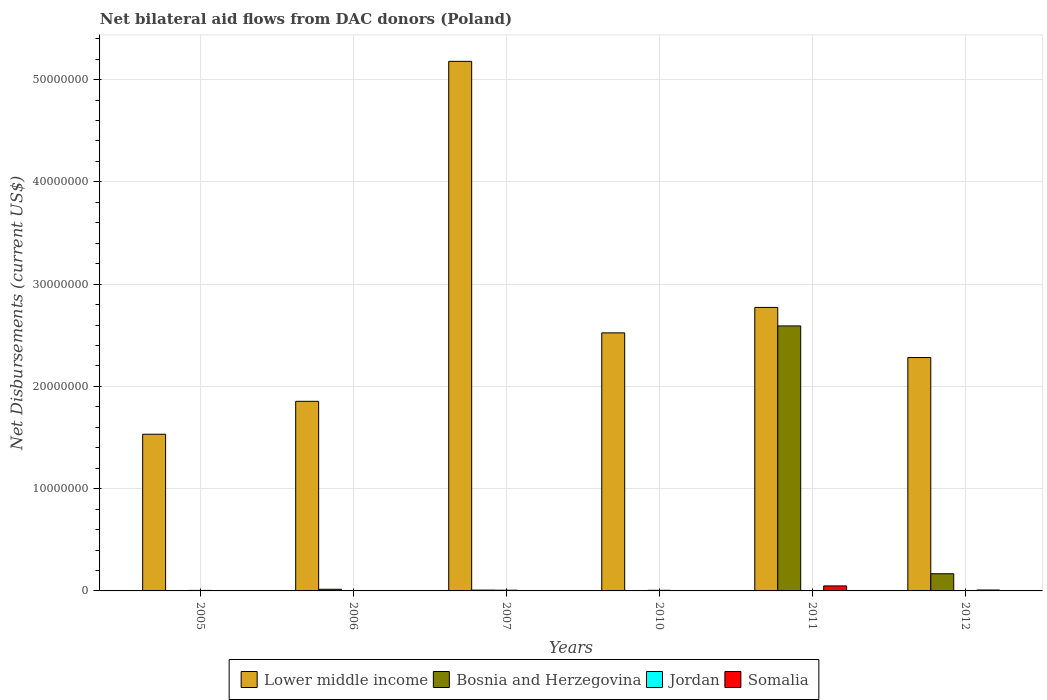How many groups of bars are there?
Give a very brief answer. 6. Are the number of bars per tick equal to the number of legend labels?
Your response must be concise. Yes. In how many cases, is the number of bars for a given year not equal to the number of legend labels?
Make the answer very short. 0. What is the net bilateral aid flows in Lower middle income in 2005?
Make the answer very short. 1.53e+07. Across all years, what is the maximum net bilateral aid flows in Bosnia and Herzegovina?
Offer a very short reply. 2.59e+07. Across all years, what is the minimum net bilateral aid flows in Jordan?
Keep it short and to the point. 10000. What is the total net bilateral aid flows in Bosnia and Herzegovina in the graph?
Provide a short and direct response. 2.78e+07. What is the difference between the net bilateral aid flows in Jordan in 2007 and that in 2010?
Offer a very short reply. 10000. What is the difference between the net bilateral aid flows in Somalia in 2007 and the net bilateral aid flows in Jordan in 2011?
Your answer should be compact. -2.00e+04. What is the average net bilateral aid flows in Somalia per year?
Your answer should be very brief. 1.07e+05. In the year 2007, what is the difference between the net bilateral aid flows in Jordan and net bilateral aid flows in Somalia?
Your answer should be very brief. 5.00e+04. What is the ratio of the net bilateral aid flows in Lower middle income in 2006 to that in 2010?
Give a very brief answer. 0.73. What is the difference between the highest and the second highest net bilateral aid flows in Somalia?
Your response must be concise. 4.00e+05. What is the difference between the highest and the lowest net bilateral aid flows in Bosnia and Herzegovina?
Make the answer very short. 2.59e+07. In how many years, is the net bilateral aid flows in Somalia greater than the average net bilateral aid flows in Somalia taken over all years?
Make the answer very short. 1. What does the 4th bar from the left in 2005 represents?
Keep it short and to the point. Somalia. What does the 4th bar from the right in 2006 represents?
Give a very brief answer. Lower middle income. Is it the case that in every year, the sum of the net bilateral aid flows in Somalia and net bilateral aid flows in Lower middle income is greater than the net bilateral aid flows in Bosnia and Herzegovina?
Your response must be concise. Yes. How many bars are there?
Your response must be concise. 24. Are all the bars in the graph horizontal?
Your answer should be very brief. No. How many years are there in the graph?
Make the answer very short. 6. Where does the legend appear in the graph?
Your answer should be very brief. Bottom center. How many legend labels are there?
Keep it short and to the point. 4. What is the title of the graph?
Ensure brevity in your answer.  Net bilateral aid flows from DAC donors (Poland). What is the label or title of the Y-axis?
Your answer should be compact. Net Disbursements (current US$). What is the Net Disbursements (current US$) of Lower middle income in 2005?
Keep it short and to the point. 1.53e+07. What is the Net Disbursements (current US$) in Bosnia and Herzegovina in 2005?
Keep it short and to the point. 10000. What is the Net Disbursements (current US$) of Jordan in 2005?
Your answer should be compact. 5.00e+04. What is the Net Disbursements (current US$) in Lower middle income in 2006?
Ensure brevity in your answer.  1.85e+07. What is the Net Disbursements (current US$) in Bosnia and Herzegovina in 2006?
Give a very brief answer. 1.60e+05. What is the Net Disbursements (current US$) of Jordan in 2006?
Provide a succinct answer. 10000. What is the Net Disbursements (current US$) in Lower middle income in 2007?
Give a very brief answer. 5.18e+07. What is the Net Disbursements (current US$) in Bosnia and Herzegovina in 2007?
Offer a terse response. 8.00e+04. What is the Net Disbursements (current US$) in Jordan in 2007?
Ensure brevity in your answer.  7.00e+04. What is the Net Disbursements (current US$) in Somalia in 2007?
Provide a short and direct response. 2.00e+04. What is the Net Disbursements (current US$) in Lower middle income in 2010?
Your answer should be compact. 2.52e+07. What is the Net Disbursements (current US$) of Bosnia and Herzegovina in 2010?
Keep it short and to the point. 10000. What is the Net Disbursements (current US$) of Somalia in 2010?
Provide a short and direct response. 10000. What is the Net Disbursements (current US$) in Lower middle income in 2011?
Ensure brevity in your answer.  2.77e+07. What is the Net Disbursements (current US$) in Bosnia and Herzegovina in 2011?
Your response must be concise. 2.59e+07. What is the Net Disbursements (current US$) of Jordan in 2011?
Provide a short and direct response. 4.00e+04. What is the Net Disbursements (current US$) of Lower middle income in 2012?
Your answer should be very brief. 2.28e+07. What is the Net Disbursements (current US$) of Bosnia and Herzegovina in 2012?
Your answer should be compact. 1.68e+06. What is the Net Disbursements (current US$) of Jordan in 2012?
Your answer should be compact. 2.00e+04. Across all years, what is the maximum Net Disbursements (current US$) in Lower middle income?
Your answer should be compact. 5.18e+07. Across all years, what is the maximum Net Disbursements (current US$) of Bosnia and Herzegovina?
Ensure brevity in your answer.  2.59e+07. Across all years, what is the maximum Net Disbursements (current US$) in Jordan?
Your answer should be very brief. 7.00e+04. Across all years, what is the maximum Net Disbursements (current US$) of Somalia?
Your answer should be very brief. 4.90e+05. Across all years, what is the minimum Net Disbursements (current US$) in Lower middle income?
Provide a short and direct response. 1.53e+07. Across all years, what is the minimum Net Disbursements (current US$) in Bosnia and Herzegovina?
Your answer should be compact. 10000. Across all years, what is the minimum Net Disbursements (current US$) in Jordan?
Ensure brevity in your answer.  10000. What is the total Net Disbursements (current US$) in Lower middle income in the graph?
Provide a succinct answer. 1.61e+08. What is the total Net Disbursements (current US$) of Bosnia and Herzegovina in the graph?
Offer a terse response. 2.78e+07. What is the total Net Disbursements (current US$) in Somalia in the graph?
Make the answer very short. 6.40e+05. What is the difference between the Net Disbursements (current US$) in Lower middle income in 2005 and that in 2006?
Give a very brief answer. -3.22e+06. What is the difference between the Net Disbursements (current US$) of Jordan in 2005 and that in 2006?
Your answer should be very brief. 4.00e+04. What is the difference between the Net Disbursements (current US$) in Somalia in 2005 and that in 2006?
Ensure brevity in your answer.  -10000. What is the difference between the Net Disbursements (current US$) in Lower middle income in 2005 and that in 2007?
Provide a short and direct response. -3.65e+07. What is the difference between the Net Disbursements (current US$) in Somalia in 2005 and that in 2007?
Provide a succinct answer. -10000. What is the difference between the Net Disbursements (current US$) of Lower middle income in 2005 and that in 2010?
Your response must be concise. -9.91e+06. What is the difference between the Net Disbursements (current US$) of Bosnia and Herzegovina in 2005 and that in 2010?
Provide a succinct answer. 0. What is the difference between the Net Disbursements (current US$) in Lower middle income in 2005 and that in 2011?
Your answer should be compact. -1.24e+07. What is the difference between the Net Disbursements (current US$) of Bosnia and Herzegovina in 2005 and that in 2011?
Ensure brevity in your answer.  -2.59e+07. What is the difference between the Net Disbursements (current US$) of Somalia in 2005 and that in 2011?
Your answer should be very brief. -4.80e+05. What is the difference between the Net Disbursements (current US$) of Lower middle income in 2005 and that in 2012?
Give a very brief answer. -7.50e+06. What is the difference between the Net Disbursements (current US$) of Bosnia and Herzegovina in 2005 and that in 2012?
Provide a succinct answer. -1.67e+06. What is the difference between the Net Disbursements (current US$) of Jordan in 2005 and that in 2012?
Make the answer very short. 3.00e+04. What is the difference between the Net Disbursements (current US$) in Somalia in 2005 and that in 2012?
Provide a short and direct response. -8.00e+04. What is the difference between the Net Disbursements (current US$) in Lower middle income in 2006 and that in 2007?
Your answer should be very brief. -3.32e+07. What is the difference between the Net Disbursements (current US$) in Lower middle income in 2006 and that in 2010?
Give a very brief answer. -6.69e+06. What is the difference between the Net Disbursements (current US$) of Bosnia and Herzegovina in 2006 and that in 2010?
Give a very brief answer. 1.50e+05. What is the difference between the Net Disbursements (current US$) in Somalia in 2006 and that in 2010?
Your answer should be compact. 10000. What is the difference between the Net Disbursements (current US$) in Lower middle income in 2006 and that in 2011?
Provide a succinct answer. -9.18e+06. What is the difference between the Net Disbursements (current US$) in Bosnia and Herzegovina in 2006 and that in 2011?
Make the answer very short. -2.58e+07. What is the difference between the Net Disbursements (current US$) in Jordan in 2006 and that in 2011?
Your answer should be compact. -3.00e+04. What is the difference between the Net Disbursements (current US$) in Somalia in 2006 and that in 2011?
Make the answer very short. -4.70e+05. What is the difference between the Net Disbursements (current US$) in Lower middle income in 2006 and that in 2012?
Your response must be concise. -4.28e+06. What is the difference between the Net Disbursements (current US$) in Bosnia and Herzegovina in 2006 and that in 2012?
Offer a terse response. -1.52e+06. What is the difference between the Net Disbursements (current US$) in Somalia in 2006 and that in 2012?
Offer a very short reply. -7.00e+04. What is the difference between the Net Disbursements (current US$) of Lower middle income in 2007 and that in 2010?
Offer a terse response. 2.66e+07. What is the difference between the Net Disbursements (current US$) in Jordan in 2007 and that in 2010?
Provide a short and direct response. 10000. What is the difference between the Net Disbursements (current US$) of Somalia in 2007 and that in 2010?
Ensure brevity in your answer.  10000. What is the difference between the Net Disbursements (current US$) in Lower middle income in 2007 and that in 2011?
Your response must be concise. 2.41e+07. What is the difference between the Net Disbursements (current US$) in Bosnia and Herzegovina in 2007 and that in 2011?
Provide a succinct answer. -2.58e+07. What is the difference between the Net Disbursements (current US$) of Somalia in 2007 and that in 2011?
Offer a very short reply. -4.70e+05. What is the difference between the Net Disbursements (current US$) in Lower middle income in 2007 and that in 2012?
Provide a succinct answer. 2.90e+07. What is the difference between the Net Disbursements (current US$) in Bosnia and Herzegovina in 2007 and that in 2012?
Provide a succinct answer. -1.60e+06. What is the difference between the Net Disbursements (current US$) in Lower middle income in 2010 and that in 2011?
Your response must be concise. -2.49e+06. What is the difference between the Net Disbursements (current US$) in Bosnia and Herzegovina in 2010 and that in 2011?
Provide a succinct answer. -2.59e+07. What is the difference between the Net Disbursements (current US$) of Jordan in 2010 and that in 2011?
Offer a terse response. 2.00e+04. What is the difference between the Net Disbursements (current US$) in Somalia in 2010 and that in 2011?
Offer a very short reply. -4.80e+05. What is the difference between the Net Disbursements (current US$) in Lower middle income in 2010 and that in 2012?
Provide a succinct answer. 2.41e+06. What is the difference between the Net Disbursements (current US$) of Bosnia and Herzegovina in 2010 and that in 2012?
Give a very brief answer. -1.67e+06. What is the difference between the Net Disbursements (current US$) in Somalia in 2010 and that in 2012?
Give a very brief answer. -8.00e+04. What is the difference between the Net Disbursements (current US$) in Lower middle income in 2011 and that in 2012?
Make the answer very short. 4.90e+06. What is the difference between the Net Disbursements (current US$) in Bosnia and Herzegovina in 2011 and that in 2012?
Give a very brief answer. 2.42e+07. What is the difference between the Net Disbursements (current US$) of Jordan in 2011 and that in 2012?
Your response must be concise. 2.00e+04. What is the difference between the Net Disbursements (current US$) of Lower middle income in 2005 and the Net Disbursements (current US$) of Bosnia and Herzegovina in 2006?
Give a very brief answer. 1.52e+07. What is the difference between the Net Disbursements (current US$) in Lower middle income in 2005 and the Net Disbursements (current US$) in Jordan in 2006?
Offer a very short reply. 1.53e+07. What is the difference between the Net Disbursements (current US$) in Lower middle income in 2005 and the Net Disbursements (current US$) in Somalia in 2006?
Offer a very short reply. 1.53e+07. What is the difference between the Net Disbursements (current US$) of Bosnia and Herzegovina in 2005 and the Net Disbursements (current US$) of Jordan in 2006?
Your answer should be compact. 0. What is the difference between the Net Disbursements (current US$) of Bosnia and Herzegovina in 2005 and the Net Disbursements (current US$) of Somalia in 2006?
Keep it short and to the point. -10000. What is the difference between the Net Disbursements (current US$) of Lower middle income in 2005 and the Net Disbursements (current US$) of Bosnia and Herzegovina in 2007?
Make the answer very short. 1.52e+07. What is the difference between the Net Disbursements (current US$) of Lower middle income in 2005 and the Net Disbursements (current US$) of Jordan in 2007?
Make the answer very short. 1.52e+07. What is the difference between the Net Disbursements (current US$) in Lower middle income in 2005 and the Net Disbursements (current US$) in Somalia in 2007?
Your answer should be compact. 1.53e+07. What is the difference between the Net Disbursements (current US$) in Jordan in 2005 and the Net Disbursements (current US$) in Somalia in 2007?
Provide a short and direct response. 3.00e+04. What is the difference between the Net Disbursements (current US$) of Lower middle income in 2005 and the Net Disbursements (current US$) of Bosnia and Herzegovina in 2010?
Offer a terse response. 1.53e+07. What is the difference between the Net Disbursements (current US$) of Lower middle income in 2005 and the Net Disbursements (current US$) of Jordan in 2010?
Your response must be concise. 1.53e+07. What is the difference between the Net Disbursements (current US$) in Lower middle income in 2005 and the Net Disbursements (current US$) in Somalia in 2010?
Your response must be concise. 1.53e+07. What is the difference between the Net Disbursements (current US$) of Bosnia and Herzegovina in 2005 and the Net Disbursements (current US$) of Somalia in 2010?
Your answer should be very brief. 0. What is the difference between the Net Disbursements (current US$) of Lower middle income in 2005 and the Net Disbursements (current US$) of Bosnia and Herzegovina in 2011?
Your answer should be very brief. -1.06e+07. What is the difference between the Net Disbursements (current US$) of Lower middle income in 2005 and the Net Disbursements (current US$) of Jordan in 2011?
Offer a terse response. 1.53e+07. What is the difference between the Net Disbursements (current US$) in Lower middle income in 2005 and the Net Disbursements (current US$) in Somalia in 2011?
Ensure brevity in your answer.  1.48e+07. What is the difference between the Net Disbursements (current US$) of Bosnia and Herzegovina in 2005 and the Net Disbursements (current US$) of Somalia in 2011?
Your answer should be very brief. -4.80e+05. What is the difference between the Net Disbursements (current US$) in Jordan in 2005 and the Net Disbursements (current US$) in Somalia in 2011?
Offer a very short reply. -4.40e+05. What is the difference between the Net Disbursements (current US$) in Lower middle income in 2005 and the Net Disbursements (current US$) in Bosnia and Herzegovina in 2012?
Provide a short and direct response. 1.36e+07. What is the difference between the Net Disbursements (current US$) of Lower middle income in 2005 and the Net Disbursements (current US$) of Jordan in 2012?
Provide a succinct answer. 1.53e+07. What is the difference between the Net Disbursements (current US$) of Lower middle income in 2005 and the Net Disbursements (current US$) of Somalia in 2012?
Your response must be concise. 1.52e+07. What is the difference between the Net Disbursements (current US$) of Bosnia and Herzegovina in 2005 and the Net Disbursements (current US$) of Jordan in 2012?
Your answer should be compact. -10000. What is the difference between the Net Disbursements (current US$) of Bosnia and Herzegovina in 2005 and the Net Disbursements (current US$) of Somalia in 2012?
Your answer should be very brief. -8.00e+04. What is the difference between the Net Disbursements (current US$) in Lower middle income in 2006 and the Net Disbursements (current US$) in Bosnia and Herzegovina in 2007?
Make the answer very short. 1.85e+07. What is the difference between the Net Disbursements (current US$) in Lower middle income in 2006 and the Net Disbursements (current US$) in Jordan in 2007?
Your response must be concise. 1.85e+07. What is the difference between the Net Disbursements (current US$) in Lower middle income in 2006 and the Net Disbursements (current US$) in Somalia in 2007?
Your response must be concise. 1.85e+07. What is the difference between the Net Disbursements (current US$) in Bosnia and Herzegovina in 2006 and the Net Disbursements (current US$) in Jordan in 2007?
Offer a terse response. 9.00e+04. What is the difference between the Net Disbursements (current US$) of Lower middle income in 2006 and the Net Disbursements (current US$) of Bosnia and Herzegovina in 2010?
Keep it short and to the point. 1.85e+07. What is the difference between the Net Disbursements (current US$) of Lower middle income in 2006 and the Net Disbursements (current US$) of Jordan in 2010?
Your response must be concise. 1.85e+07. What is the difference between the Net Disbursements (current US$) in Lower middle income in 2006 and the Net Disbursements (current US$) in Somalia in 2010?
Offer a terse response. 1.85e+07. What is the difference between the Net Disbursements (current US$) of Bosnia and Herzegovina in 2006 and the Net Disbursements (current US$) of Jordan in 2010?
Your answer should be very brief. 1.00e+05. What is the difference between the Net Disbursements (current US$) in Bosnia and Herzegovina in 2006 and the Net Disbursements (current US$) in Somalia in 2010?
Offer a very short reply. 1.50e+05. What is the difference between the Net Disbursements (current US$) of Jordan in 2006 and the Net Disbursements (current US$) of Somalia in 2010?
Keep it short and to the point. 0. What is the difference between the Net Disbursements (current US$) of Lower middle income in 2006 and the Net Disbursements (current US$) of Bosnia and Herzegovina in 2011?
Keep it short and to the point. -7.37e+06. What is the difference between the Net Disbursements (current US$) of Lower middle income in 2006 and the Net Disbursements (current US$) of Jordan in 2011?
Your answer should be compact. 1.85e+07. What is the difference between the Net Disbursements (current US$) of Lower middle income in 2006 and the Net Disbursements (current US$) of Somalia in 2011?
Your answer should be compact. 1.80e+07. What is the difference between the Net Disbursements (current US$) in Bosnia and Herzegovina in 2006 and the Net Disbursements (current US$) in Jordan in 2011?
Your answer should be compact. 1.20e+05. What is the difference between the Net Disbursements (current US$) of Bosnia and Herzegovina in 2006 and the Net Disbursements (current US$) of Somalia in 2011?
Offer a very short reply. -3.30e+05. What is the difference between the Net Disbursements (current US$) in Jordan in 2006 and the Net Disbursements (current US$) in Somalia in 2011?
Offer a terse response. -4.80e+05. What is the difference between the Net Disbursements (current US$) in Lower middle income in 2006 and the Net Disbursements (current US$) in Bosnia and Herzegovina in 2012?
Your answer should be compact. 1.69e+07. What is the difference between the Net Disbursements (current US$) in Lower middle income in 2006 and the Net Disbursements (current US$) in Jordan in 2012?
Give a very brief answer. 1.85e+07. What is the difference between the Net Disbursements (current US$) of Lower middle income in 2006 and the Net Disbursements (current US$) of Somalia in 2012?
Give a very brief answer. 1.84e+07. What is the difference between the Net Disbursements (current US$) of Bosnia and Herzegovina in 2006 and the Net Disbursements (current US$) of Jordan in 2012?
Offer a terse response. 1.40e+05. What is the difference between the Net Disbursements (current US$) in Bosnia and Herzegovina in 2006 and the Net Disbursements (current US$) in Somalia in 2012?
Ensure brevity in your answer.  7.00e+04. What is the difference between the Net Disbursements (current US$) in Lower middle income in 2007 and the Net Disbursements (current US$) in Bosnia and Herzegovina in 2010?
Your response must be concise. 5.18e+07. What is the difference between the Net Disbursements (current US$) of Lower middle income in 2007 and the Net Disbursements (current US$) of Jordan in 2010?
Offer a very short reply. 5.17e+07. What is the difference between the Net Disbursements (current US$) of Lower middle income in 2007 and the Net Disbursements (current US$) of Somalia in 2010?
Give a very brief answer. 5.18e+07. What is the difference between the Net Disbursements (current US$) of Bosnia and Herzegovina in 2007 and the Net Disbursements (current US$) of Somalia in 2010?
Your response must be concise. 7.00e+04. What is the difference between the Net Disbursements (current US$) of Lower middle income in 2007 and the Net Disbursements (current US$) of Bosnia and Herzegovina in 2011?
Make the answer very short. 2.59e+07. What is the difference between the Net Disbursements (current US$) in Lower middle income in 2007 and the Net Disbursements (current US$) in Jordan in 2011?
Your answer should be very brief. 5.17e+07. What is the difference between the Net Disbursements (current US$) of Lower middle income in 2007 and the Net Disbursements (current US$) of Somalia in 2011?
Your response must be concise. 5.13e+07. What is the difference between the Net Disbursements (current US$) of Bosnia and Herzegovina in 2007 and the Net Disbursements (current US$) of Somalia in 2011?
Ensure brevity in your answer.  -4.10e+05. What is the difference between the Net Disbursements (current US$) in Jordan in 2007 and the Net Disbursements (current US$) in Somalia in 2011?
Ensure brevity in your answer.  -4.20e+05. What is the difference between the Net Disbursements (current US$) in Lower middle income in 2007 and the Net Disbursements (current US$) in Bosnia and Herzegovina in 2012?
Offer a terse response. 5.01e+07. What is the difference between the Net Disbursements (current US$) in Lower middle income in 2007 and the Net Disbursements (current US$) in Jordan in 2012?
Make the answer very short. 5.18e+07. What is the difference between the Net Disbursements (current US$) of Lower middle income in 2007 and the Net Disbursements (current US$) of Somalia in 2012?
Your answer should be compact. 5.17e+07. What is the difference between the Net Disbursements (current US$) in Lower middle income in 2010 and the Net Disbursements (current US$) in Bosnia and Herzegovina in 2011?
Provide a short and direct response. -6.80e+05. What is the difference between the Net Disbursements (current US$) of Lower middle income in 2010 and the Net Disbursements (current US$) of Jordan in 2011?
Offer a very short reply. 2.52e+07. What is the difference between the Net Disbursements (current US$) in Lower middle income in 2010 and the Net Disbursements (current US$) in Somalia in 2011?
Provide a short and direct response. 2.47e+07. What is the difference between the Net Disbursements (current US$) of Bosnia and Herzegovina in 2010 and the Net Disbursements (current US$) of Somalia in 2011?
Give a very brief answer. -4.80e+05. What is the difference between the Net Disbursements (current US$) of Jordan in 2010 and the Net Disbursements (current US$) of Somalia in 2011?
Provide a succinct answer. -4.30e+05. What is the difference between the Net Disbursements (current US$) in Lower middle income in 2010 and the Net Disbursements (current US$) in Bosnia and Herzegovina in 2012?
Offer a very short reply. 2.36e+07. What is the difference between the Net Disbursements (current US$) of Lower middle income in 2010 and the Net Disbursements (current US$) of Jordan in 2012?
Your answer should be compact. 2.52e+07. What is the difference between the Net Disbursements (current US$) of Lower middle income in 2010 and the Net Disbursements (current US$) of Somalia in 2012?
Give a very brief answer. 2.51e+07. What is the difference between the Net Disbursements (current US$) of Bosnia and Herzegovina in 2010 and the Net Disbursements (current US$) of Jordan in 2012?
Offer a terse response. -10000. What is the difference between the Net Disbursements (current US$) of Bosnia and Herzegovina in 2010 and the Net Disbursements (current US$) of Somalia in 2012?
Your answer should be compact. -8.00e+04. What is the difference between the Net Disbursements (current US$) of Lower middle income in 2011 and the Net Disbursements (current US$) of Bosnia and Herzegovina in 2012?
Keep it short and to the point. 2.60e+07. What is the difference between the Net Disbursements (current US$) in Lower middle income in 2011 and the Net Disbursements (current US$) in Jordan in 2012?
Make the answer very short. 2.77e+07. What is the difference between the Net Disbursements (current US$) in Lower middle income in 2011 and the Net Disbursements (current US$) in Somalia in 2012?
Your answer should be very brief. 2.76e+07. What is the difference between the Net Disbursements (current US$) in Bosnia and Herzegovina in 2011 and the Net Disbursements (current US$) in Jordan in 2012?
Offer a terse response. 2.59e+07. What is the difference between the Net Disbursements (current US$) in Bosnia and Herzegovina in 2011 and the Net Disbursements (current US$) in Somalia in 2012?
Provide a short and direct response. 2.58e+07. What is the average Net Disbursements (current US$) of Lower middle income per year?
Offer a terse response. 2.69e+07. What is the average Net Disbursements (current US$) of Bosnia and Herzegovina per year?
Give a very brief answer. 4.64e+06. What is the average Net Disbursements (current US$) in Jordan per year?
Your response must be concise. 4.17e+04. What is the average Net Disbursements (current US$) in Somalia per year?
Your response must be concise. 1.07e+05. In the year 2005, what is the difference between the Net Disbursements (current US$) in Lower middle income and Net Disbursements (current US$) in Bosnia and Herzegovina?
Give a very brief answer. 1.53e+07. In the year 2005, what is the difference between the Net Disbursements (current US$) in Lower middle income and Net Disbursements (current US$) in Jordan?
Your response must be concise. 1.53e+07. In the year 2005, what is the difference between the Net Disbursements (current US$) of Lower middle income and Net Disbursements (current US$) of Somalia?
Give a very brief answer. 1.53e+07. In the year 2005, what is the difference between the Net Disbursements (current US$) of Bosnia and Herzegovina and Net Disbursements (current US$) of Somalia?
Give a very brief answer. 0. In the year 2005, what is the difference between the Net Disbursements (current US$) in Jordan and Net Disbursements (current US$) in Somalia?
Offer a very short reply. 4.00e+04. In the year 2006, what is the difference between the Net Disbursements (current US$) in Lower middle income and Net Disbursements (current US$) in Bosnia and Herzegovina?
Keep it short and to the point. 1.84e+07. In the year 2006, what is the difference between the Net Disbursements (current US$) in Lower middle income and Net Disbursements (current US$) in Jordan?
Provide a succinct answer. 1.85e+07. In the year 2006, what is the difference between the Net Disbursements (current US$) of Lower middle income and Net Disbursements (current US$) of Somalia?
Your response must be concise. 1.85e+07. In the year 2006, what is the difference between the Net Disbursements (current US$) in Bosnia and Herzegovina and Net Disbursements (current US$) in Jordan?
Offer a terse response. 1.50e+05. In the year 2006, what is the difference between the Net Disbursements (current US$) of Bosnia and Herzegovina and Net Disbursements (current US$) of Somalia?
Your response must be concise. 1.40e+05. In the year 2006, what is the difference between the Net Disbursements (current US$) of Jordan and Net Disbursements (current US$) of Somalia?
Your answer should be compact. -10000. In the year 2007, what is the difference between the Net Disbursements (current US$) in Lower middle income and Net Disbursements (current US$) in Bosnia and Herzegovina?
Your response must be concise. 5.17e+07. In the year 2007, what is the difference between the Net Disbursements (current US$) in Lower middle income and Net Disbursements (current US$) in Jordan?
Ensure brevity in your answer.  5.17e+07. In the year 2007, what is the difference between the Net Disbursements (current US$) in Lower middle income and Net Disbursements (current US$) in Somalia?
Ensure brevity in your answer.  5.18e+07. In the year 2007, what is the difference between the Net Disbursements (current US$) in Bosnia and Herzegovina and Net Disbursements (current US$) in Jordan?
Provide a succinct answer. 10000. In the year 2010, what is the difference between the Net Disbursements (current US$) of Lower middle income and Net Disbursements (current US$) of Bosnia and Herzegovina?
Offer a terse response. 2.52e+07. In the year 2010, what is the difference between the Net Disbursements (current US$) of Lower middle income and Net Disbursements (current US$) of Jordan?
Keep it short and to the point. 2.52e+07. In the year 2010, what is the difference between the Net Disbursements (current US$) in Lower middle income and Net Disbursements (current US$) in Somalia?
Your answer should be very brief. 2.52e+07. In the year 2010, what is the difference between the Net Disbursements (current US$) in Bosnia and Herzegovina and Net Disbursements (current US$) in Jordan?
Provide a succinct answer. -5.00e+04. In the year 2010, what is the difference between the Net Disbursements (current US$) of Jordan and Net Disbursements (current US$) of Somalia?
Ensure brevity in your answer.  5.00e+04. In the year 2011, what is the difference between the Net Disbursements (current US$) in Lower middle income and Net Disbursements (current US$) in Bosnia and Herzegovina?
Your answer should be very brief. 1.81e+06. In the year 2011, what is the difference between the Net Disbursements (current US$) of Lower middle income and Net Disbursements (current US$) of Jordan?
Your response must be concise. 2.77e+07. In the year 2011, what is the difference between the Net Disbursements (current US$) of Lower middle income and Net Disbursements (current US$) of Somalia?
Keep it short and to the point. 2.72e+07. In the year 2011, what is the difference between the Net Disbursements (current US$) of Bosnia and Herzegovina and Net Disbursements (current US$) of Jordan?
Provide a succinct answer. 2.59e+07. In the year 2011, what is the difference between the Net Disbursements (current US$) in Bosnia and Herzegovina and Net Disbursements (current US$) in Somalia?
Your response must be concise. 2.54e+07. In the year 2011, what is the difference between the Net Disbursements (current US$) of Jordan and Net Disbursements (current US$) of Somalia?
Your answer should be very brief. -4.50e+05. In the year 2012, what is the difference between the Net Disbursements (current US$) in Lower middle income and Net Disbursements (current US$) in Bosnia and Herzegovina?
Offer a terse response. 2.11e+07. In the year 2012, what is the difference between the Net Disbursements (current US$) of Lower middle income and Net Disbursements (current US$) of Jordan?
Offer a very short reply. 2.28e+07. In the year 2012, what is the difference between the Net Disbursements (current US$) in Lower middle income and Net Disbursements (current US$) in Somalia?
Give a very brief answer. 2.27e+07. In the year 2012, what is the difference between the Net Disbursements (current US$) in Bosnia and Herzegovina and Net Disbursements (current US$) in Jordan?
Keep it short and to the point. 1.66e+06. In the year 2012, what is the difference between the Net Disbursements (current US$) of Bosnia and Herzegovina and Net Disbursements (current US$) of Somalia?
Ensure brevity in your answer.  1.59e+06. What is the ratio of the Net Disbursements (current US$) in Lower middle income in 2005 to that in 2006?
Give a very brief answer. 0.83. What is the ratio of the Net Disbursements (current US$) in Bosnia and Herzegovina in 2005 to that in 2006?
Keep it short and to the point. 0.06. What is the ratio of the Net Disbursements (current US$) in Jordan in 2005 to that in 2006?
Ensure brevity in your answer.  5. What is the ratio of the Net Disbursements (current US$) in Somalia in 2005 to that in 2006?
Offer a terse response. 0.5. What is the ratio of the Net Disbursements (current US$) of Lower middle income in 2005 to that in 2007?
Your response must be concise. 0.3. What is the ratio of the Net Disbursements (current US$) of Somalia in 2005 to that in 2007?
Your response must be concise. 0.5. What is the ratio of the Net Disbursements (current US$) of Lower middle income in 2005 to that in 2010?
Your response must be concise. 0.61. What is the ratio of the Net Disbursements (current US$) in Jordan in 2005 to that in 2010?
Provide a succinct answer. 0.83. What is the ratio of the Net Disbursements (current US$) in Lower middle income in 2005 to that in 2011?
Provide a short and direct response. 0.55. What is the ratio of the Net Disbursements (current US$) of Jordan in 2005 to that in 2011?
Provide a succinct answer. 1.25. What is the ratio of the Net Disbursements (current US$) in Somalia in 2005 to that in 2011?
Your answer should be very brief. 0.02. What is the ratio of the Net Disbursements (current US$) of Lower middle income in 2005 to that in 2012?
Provide a short and direct response. 0.67. What is the ratio of the Net Disbursements (current US$) of Bosnia and Herzegovina in 2005 to that in 2012?
Offer a terse response. 0.01. What is the ratio of the Net Disbursements (current US$) of Somalia in 2005 to that in 2012?
Your answer should be very brief. 0.11. What is the ratio of the Net Disbursements (current US$) in Lower middle income in 2006 to that in 2007?
Your answer should be compact. 0.36. What is the ratio of the Net Disbursements (current US$) of Bosnia and Herzegovina in 2006 to that in 2007?
Give a very brief answer. 2. What is the ratio of the Net Disbursements (current US$) of Jordan in 2006 to that in 2007?
Keep it short and to the point. 0.14. What is the ratio of the Net Disbursements (current US$) in Lower middle income in 2006 to that in 2010?
Give a very brief answer. 0.73. What is the ratio of the Net Disbursements (current US$) in Bosnia and Herzegovina in 2006 to that in 2010?
Give a very brief answer. 16. What is the ratio of the Net Disbursements (current US$) in Jordan in 2006 to that in 2010?
Keep it short and to the point. 0.17. What is the ratio of the Net Disbursements (current US$) in Lower middle income in 2006 to that in 2011?
Your answer should be very brief. 0.67. What is the ratio of the Net Disbursements (current US$) of Bosnia and Herzegovina in 2006 to that in 2011?
Provide a succinct answer. 0.01. What is the ratio of the Net Disbursements (current US$) in Somalia in 2006 to that in 2011?
Ensure brevity in your answer.  0.04. What is the ratio of the Net Disbursements (current US$) in Lower middle income in 2006 to that in 2012?
Make the answer very short. 0.81. What is the ratio of the Net Disbursements (current US$) of Bosnia and Herzegovina in 2006 to that in 2012?
Provide a short and direct response. 0.1. What is the ratio of the Net Disbursements (current US$) in Jordan in 2006 to that in 2012?
Your answer should be compact. 0.5. What is the ratio of the Net Disbursements (current US$) of Somalia in 2006 to that in 2012?
Provide a succinct answer. 0.22. What is the ratio of the Net Disbursements (current US$) of Lower middle income in 2007 to that in 2010?
Your answer should be compact. 2.05. What is the ratio of the Net Disbursements (current US$) in Jordan in 2007 to that in 2010?
Offer a very short reply. 1.17. What is the ratio of the Net Disbursements (current US$) of Lower middle income in 2007 to that in 2011?
Provide a short and direct response. 1.87. What is the ratio of the Net Disbursements (current US$) of Bosnia and Herzegovina in 2007 to that in 2011?
Keep it short and to the point. 0. What is the ratio of the Net Disbursements (current US$) in Jordan in 2007 to that in 2011?
Keep it short and to the point. 1.75. What is the ratio of the Net Disbursements (current US$) of Somalia in 2007 to that in 2011?
Ensure brevity in your answer.  0.04. What is the ratio of the Net Disbursements (current US$) of Lower middle income in 2007 to that in 2012?
Your answer should be very brief. 2.27. What is the ratio of the Net Disbursements (current US$) of Bosnia and Herzegovina in 2007 to that in 2012?
Your answer should be very brief. 0.05. What is the ratio of the Net Disbursements (current US$) of Somalia in 2007 to that in 2012?
Offer a very short reply. 0.22. What is the ratio of the Net Disbursements (current US$) of Lower middle income in 2010 to that in 2011?
Ensure brevity in your answer.  0.91. What is the ratio of the Net Disbursements (current US$) of Jordan in 2010 to that in 2011?
Your answer should be very brief. 1.5. What is the ratio of the Net Disbursements (current US$) in Somalia in 2010 to that in 2011?
Offer a very short reply. 0.02. What is the ratio of the Net Disbursements (current US$) in Lower middle income in 2010 to that in 2012?
Keep it short and to the point. 1.11. What is the ratio of the Net Disbursements (current US$) in Bosnia and Herzegovina in 2010 to that in 2012?
Your answer should be compact. 0.01. What is the ratio of the Net Disbursements (current US$) in Jordan in 2010 to that in 2012?
Your response must be concise. 3. What is the ratio of the Net Disbursements (current US$) in Lower middle income in 2011 to that in 2012?
Provide a short and direct response. 1.21. What is the ratio of the Net Disbursements (current US$) in Bosnia and Herzegovina in 2011 to that in 2012?
Your answer should be compact. 15.42. What is the ratio of the Net Disbursements (current US$) in Somalia in 2011 to that in 2012?
Keep it short and to the point. 5.44. What is the difference between the highest and the second highest Net Disbursements (current US$) of Lower middle income?
Keep it short and to the point. 2.41e+07. What is the difference between the highest and the second highest Net Disbursements (current US$) in Bosnia and Herzegovina?
Offer a very short reply. 2.42e+07. What is the difference between the highest and the second highest Net Disbursements (current US$) in Somalia?
Ensure brevity in your answer.  4.00e+05. What is the difference between the highest and the lowest Net Disbursements (current US$) of Lower middle income?
Give a very brief answer. 3.65e+07. What is the difference between the highest and the lowest Net Disbursements (current US$) of Bosnia and Herzegovina?
Make the answer very short. 2.59e+07. What is the difference between the highest and the lowest Net Disbursements (current US$) in Somalia?
Your answer should be compact. 4.80e+05. 